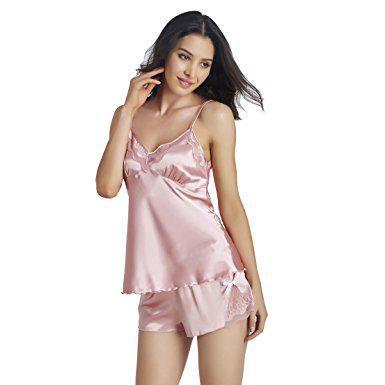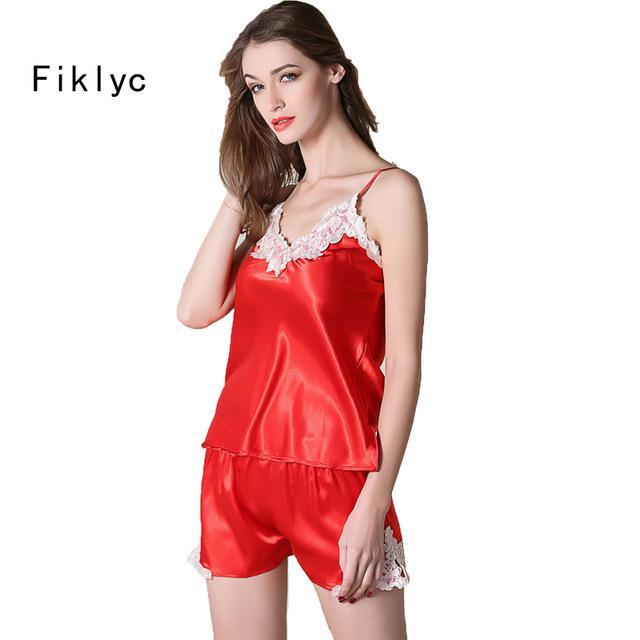The first image is the image on the left, the second image is the image on the right. For the images shown, is this caption "there is a silky cami set with white lace on the chest" true? Answer yes or no. Yes. The first image is the image on the left, the second image is the image on the right. Examine the images to the left and right. Is the description "Each image shows one model wearing a lingerie set featuring a camisole top and boy-short bottom made of non-printed satiny fabric." accurate? Answer yes or no. Yes. 